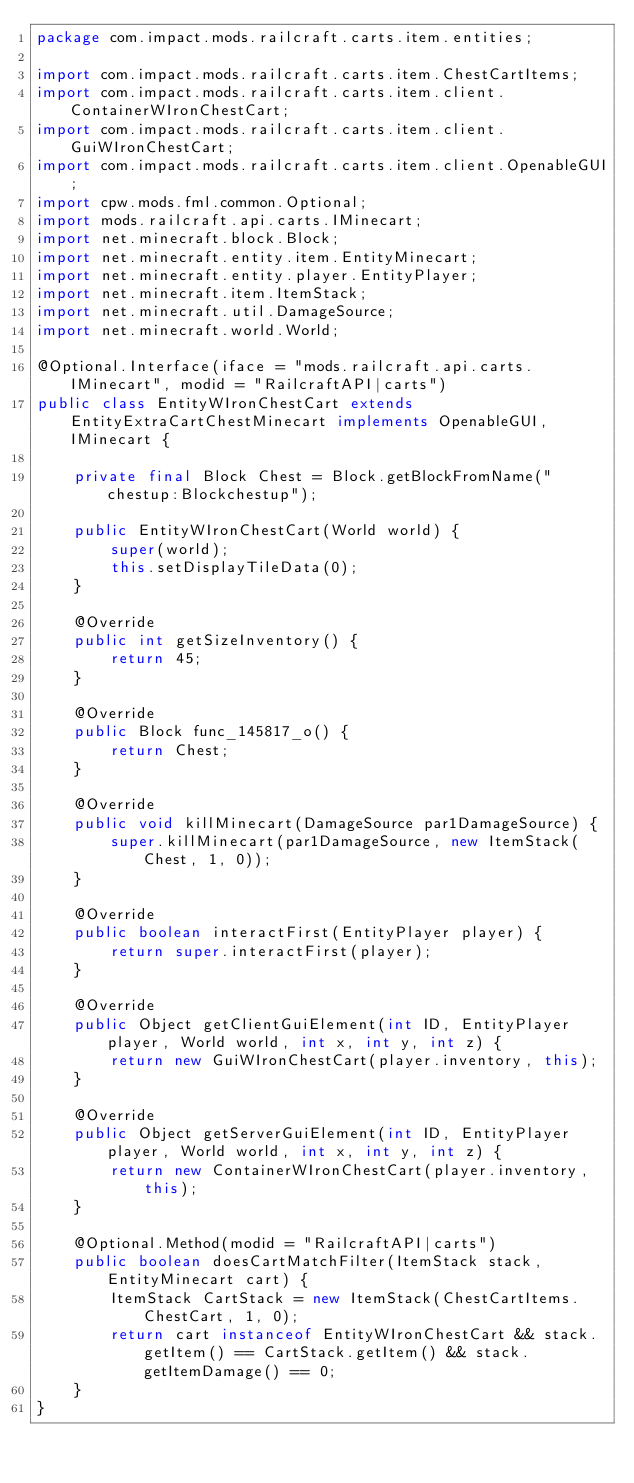<code> <loc_0><loc_0><loc_500><loc_500><_Java_>package com.impact.mods.railcraft.carts.item.entities;

import com.impact.mods.railcraft.carts.item.ChestCartItems;
import com.impact.mods.railcraft.carts.item.client.ContainerWIronChestCart;
import com.impact.mods.railcraft.carts.item.client.GuiWIronChestCart;
import com.impact.mods.railcraft.carts.item.client.OpenableGUI;
import cpw.mods.fml.common.Optional;
import mods.railcraft.api.carts.IMinecart;
import net.minecraft.block.Block;
import net.minecraft.entity.item.EntityMinecart;
import net.minecraft.entity.player.EntityPlayer;
import net.minecraft.item.ItemStack;
import net.minecraft.util.DamageSource;
import net.minecraft.world.World;

@Optional.Interface(iface = "mods.railcraft.api.carts.IMinecart", modid = "RailcraftAPI|carts")
public class EntityWIronChestCart extends EntityExtraCartChestMinecart implements OpenableGUI, IMinecart {
	
	private final Block Chest = Block.getBlockFromName("chestup:Blockchestup");
	
	public EntityWIronChestCart(World world) {
		super(world);
		this.setDisplayTileData(0);
	}
	
	@Override
	public int getSizeInventory() {
		return 45;
	}
	
	@Override
	public Block func_145817_o() {
		return Chest;
	}
	
	@Override
	public void killMinecart(DamageSource par1DamageSource) {
		super.killMinecart(par1DamageSource, new ItemStack(Chest, 1, 0));
	}
	
	@Override
	public boolean interactFirst(EntityPlayer player) {
		return super.interactFirst(player);
	}
	
	@Override
	public Object getClientGuiElement(int ID, EntityPlayer player, World world, int x, int y, int z) {
		return new GuiWIronChestCart(player.inventory, this);
	}
	
	@Override
	public Object getServerGuiElement(int ID, EntityPlayer player, World world, int x, int y, int z) {
		return new ContainerWIronChestCart(player.inventory, this);
	}
	
	@Optional.Method(modid = "RailcraftAPI|carts")
	public boolean doesCartMatchFilter(ItemStack stack, EntityMinecart cart) {
		ItemStack CartStack = new ItemStack(ChestCartItems.ChestCart, 1, 0);
		return cart instanceof EntityWIronChestCart && stack.getItem() == CartStack.getItem() && stack.getItemDamage() == 0;
	}
}
</code> 